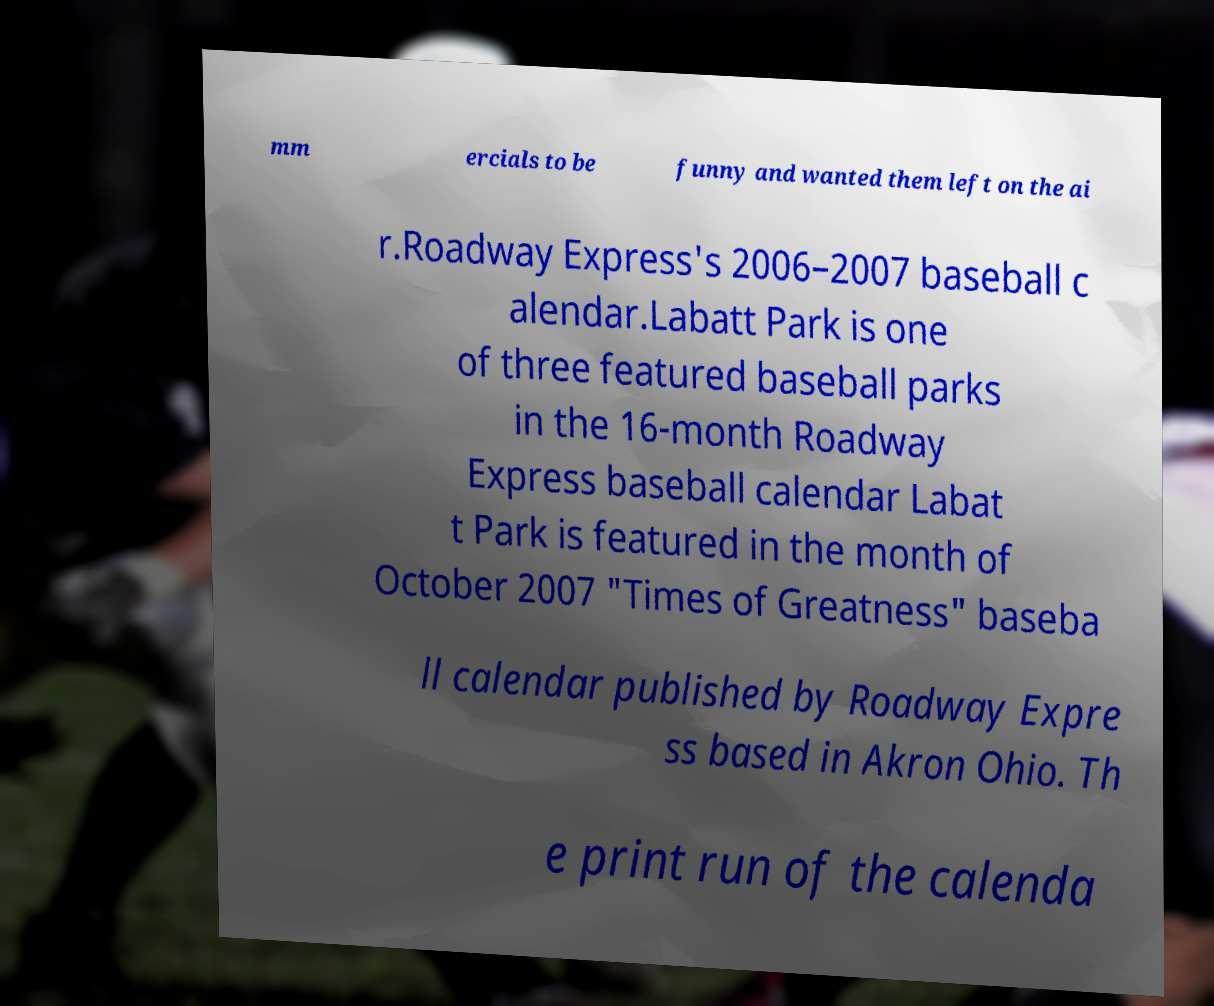Please read and relay the text visible in this image. What does it say? mm ercials to be funny and wanted them left on the ai r.Roadway Express's 2006–2007 baseball c alendar.Labatt Park is one of three featured baseball parks in the 16-month Roadway Express baseball calendar Labat t Park is featured in the month of October 2007 "Times of Greatness" baseba ll calendar published by Roadway Expre ss based in Akron Ohio. Th e print run of the calenda 